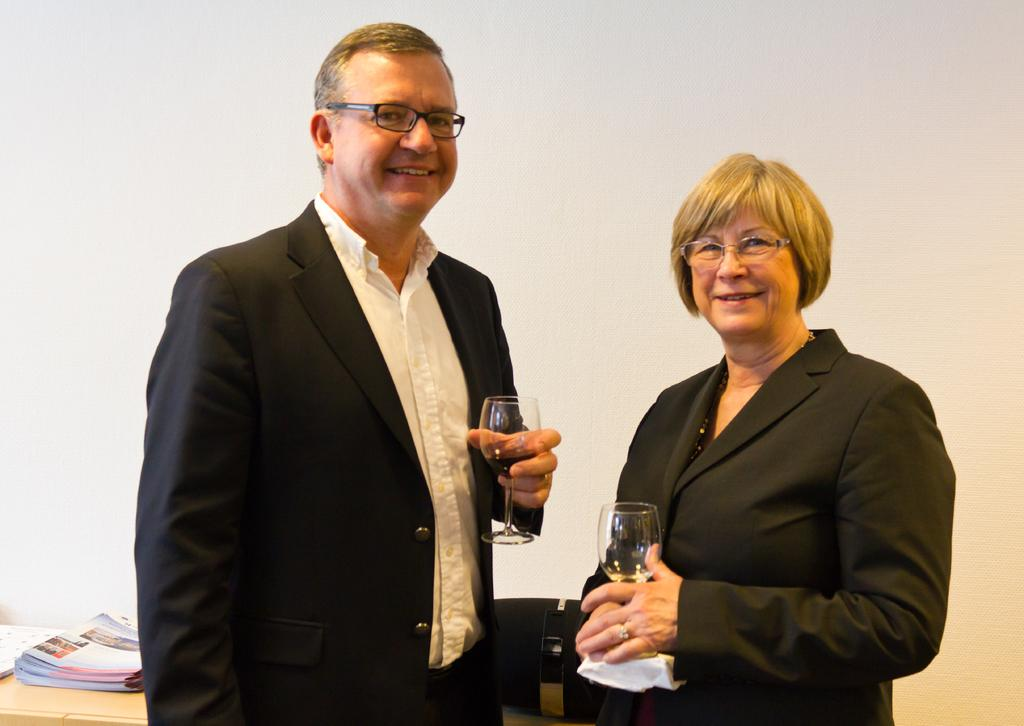How many people are in the image? There are two persons in the image. What are the persons doing in the image? The persons are standing and holding a glass. What is present on the table in the image? There are books on the table. What can be seen in the background of the image? There is a wall in the background of the image. What type of boot is placed on the table in the image? There is no boot present on the table in the image. What impulse might have caused the persons to hold the glass in the image? The image does not provide information about the impulse or motivation behind the persons holding the glass. 